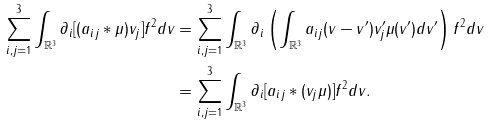<formula> <loc_0><loc_0><loc_500><loc_500>\sum _ { i , j = 1 } ^ { 3 } \int _ { \mathbb { R } ^ { 3 } } \partial _ { i } [ ( a _ { i j } * \mu ) v _ { j } ] f ^ { 2 } d v & = \sum _ { i , j = 1 } ^ { 3 } \int _ { \mathbb { R } ^ { 3 } } \partial _ { i } \left ( \int _ { \mathbb { R } ^ { 3 } } a _ { i j } ( v - v ^ { \prime } ) v _ { j } ^ { \prime } \mu ( v ^ { \prime } ) d v ^ { \prime } \right ) f ^ { 2 } d v \\ & = \sum _ { i , j = 1 } ^ { 3 } \int _ { \mathbb { R } ^ { 3 } } \partial _ { i } [ a _ { i j } * ( v _ { j } \mu ) ] f ^ { 2 } d v .</formula> 